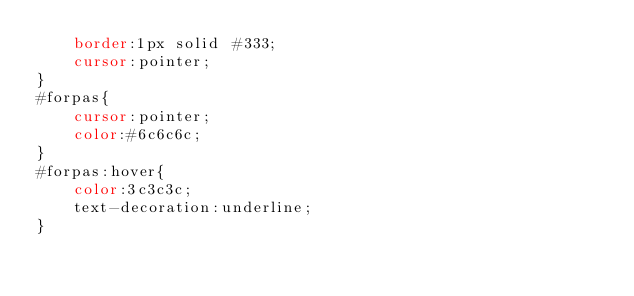Convert code to text. <code><loc_0><loc_0><loc_500><loc_500><_CSS_>	border:1px solid #333;
	cursor:pointer;
}
#forpas{
	cursor:pointer;
	color:#6c6c6c;
}
#forpas:hover{
	color:3c3c3c;
	text-decoration:underline;
}</code> 